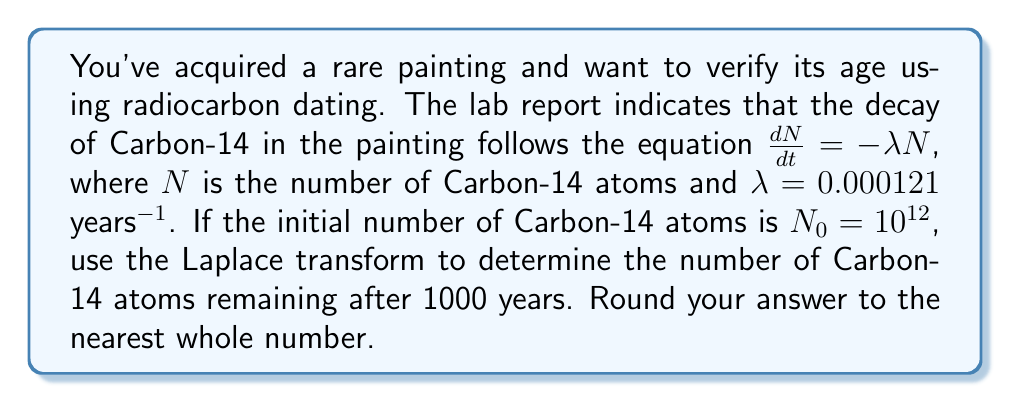Can you solve this math problem? Let's approach this step-by-step using the Laplace transform:

1) The differential equation is $\frac{dN}{dt} = -\lambda N$ with initial condition $N(0) = N_0 = 10^{12}$.

2) Taking the Laplace transform of both sides:
   $$\mathcal{L}\left\{\frac{dN}{dt}\right\} = \mathcal{L}\{-\lambda N\}$$

3) Using the property of Laplace transform for derivatives:
   $$s\mathcal{L}\{N\} - N(0) = -\lambda \mathcal{L}\{N\}$$

4) Let $\mathcal{L}\{N\} = X(s)$. Substituting and rearranging:
   $$sX(s) - N_0 = -\lambda X(s)$$
   $$X(s)(s + \lambda) = N_0$$
   $$X(s) = \frac{N_0}{s + \lambda}$$

5) The inverse Laplace transform of $\frac{1}{s + a}$ is $e^{-at}$. Therefore:
   $$N(t) = N_0 e^{-\lambda t}$$

6) Substituting the values:
   $$N(1000) = 10^{12} \cdot e^{-0.000121 \cdot 1000}$$

7) Calculating:
   $$N(1000) = 10^{12} \cdot e^{-0.121} \approx 8.86 \times 10^{11}$$

8) Rounding to the nearest whole number:
   $$N(1000) \approx 886,000,000,000$$
Answer: 886,000,000,000 Carbon-14 atoms 